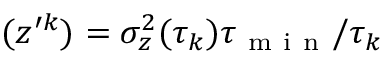<formula> <loc_0><loc_0><loc_500><loc_500>( z ^ { \prime k } ) = \sigma _ { z } ^ { 2 } ( \tau _ { k } ) \tau _ { m i n } / \tau _ { k }</formula> 